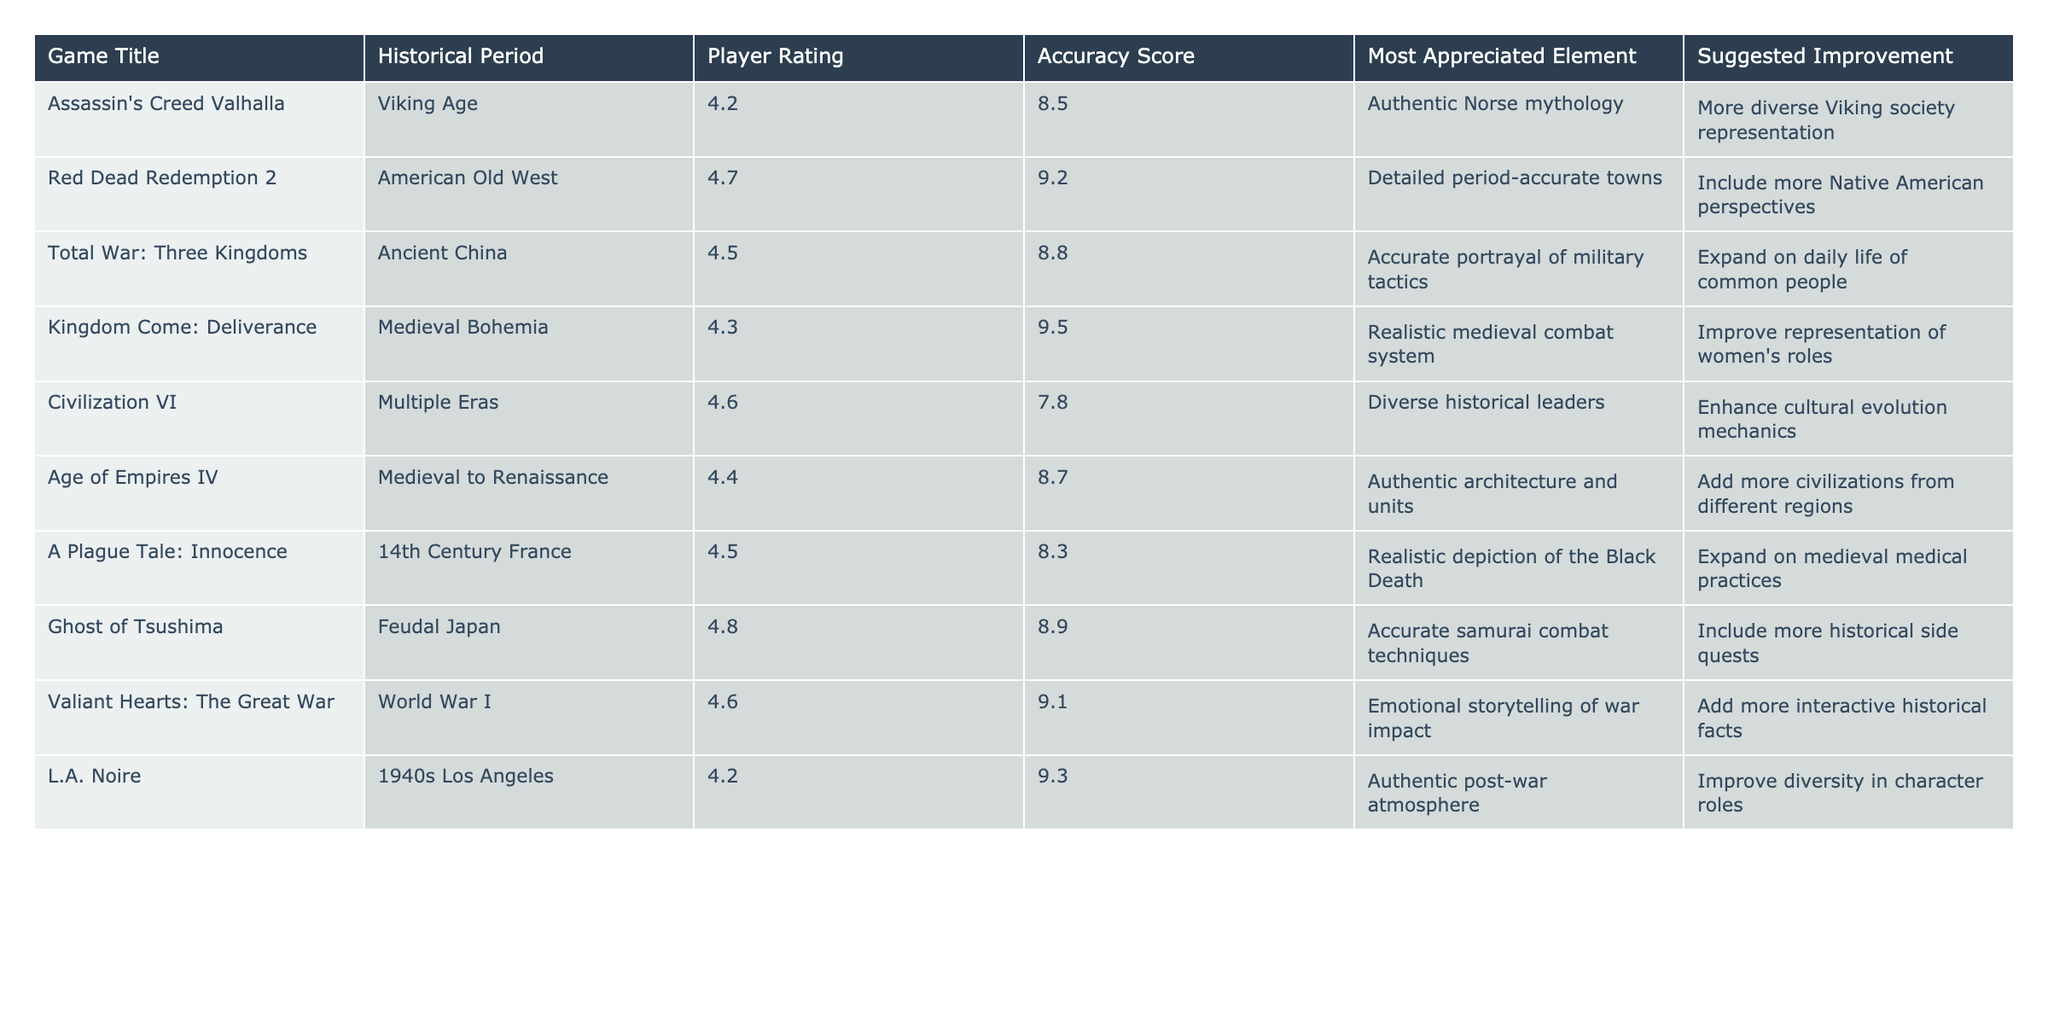What is the player rating for Ghost of Tsushima? The table lists the player rating for Ghost of Tsushima under the "Player Rating" column, which is 4.8.
Answer: 4.8 Which game has the highest accuracy score? By comparing the "Accuracy Score" for all games in the table, Red Dead Redemption 2 has the highest score of 9.2.
Answer: Red Dead Redemption 2 What is the average player rating of the games listed? To find the average, sum the ratings (4.2 + 4.7 + 4.5 + 4.3 + 4.6 + 4.4 + 4.5 + 4.8 + 4.6 + 4.2 = 45.8) and divide by the total number of games (10). So, 45.8 / 10 = 4.58.
Answer: 4.58 Which game had players suggesting improvements related to diversity? The games where diversity was mentioned for improvements are Red Dead Redemption 2 and L.A. Noire, based on the "Suggested Improvement" column.
Answer: Red Dead Redemption 2 and L.A. Noire How does the accuracy score of A Plague Tale: Innocence compare to that of Kingdom Come: Deliverance? The accuracy score for A Plague Tale: Innocence is 8.3, while for Kingdom Come: Deliverance, it is 9.5. Since 8.3 is less than 9.5, A Plague Tale: Innocence has a lower accuracy score than Kingdom Come: Deliverance.
Answer: A Plague Tale: Innocence has a lower accuracy score Is emotional storytelling appreciated more in Valiant Hearts: The Great War than in Total War: Three Kingdoms? The table indicates that Valiant Hearts: The Great War is appreciated for its emotional storytelling, while Total War: Three Kingdoms is appreciated for military tactics. This means emotional storytelling is appreciated in one game and not mentioned for the other, making a direct comparison unclear based on appreciation alone.
Answer: No What unique aspect does Age of Empires IV appreciate compared to Civilization VI? The table states that Age of Empires IV appreciates "Authentic architecture and units," while Civilization VI appreciates "Diverse historical leaders." These elements highlight different focuses in gameplay style; thus, they do not overlap.
Answer: Different focuses (architecture vs. leaders) Would you say that the player rating is consistently high across all games? Evaluating the player ratings listed in the table shows that all games have ratings above 4.0, with the lowest being 4.2, indicating that ratings are generally high. Therefore, it’s reasonable to conclude that the ratings are consistently high.
Answer: Yes Which historical period appears to have the highest player rating across the games listed? By examining the "Player Rating" column along with their respective historical periods, Red Dead Redemption 2 (American Old West) has the highest rating at 4.7, indicating its period has a high player rating among the games listed.
Answer: American Old West How many games have a player rating of 4.5 or higher? Five out of ten games listed have player ratings of 4.5 or higher (4.5, 4.6, 4.7, 4.8). Therefore, the number of games is 6.
Answer: 6 What is the suggested improvement for Kingdom Come: Deliverance? The suggested improvement for Kingdom Come: Deliverance listed in the table is "Improve representation of women's roles."
Answer: Improve representation of women's roles 